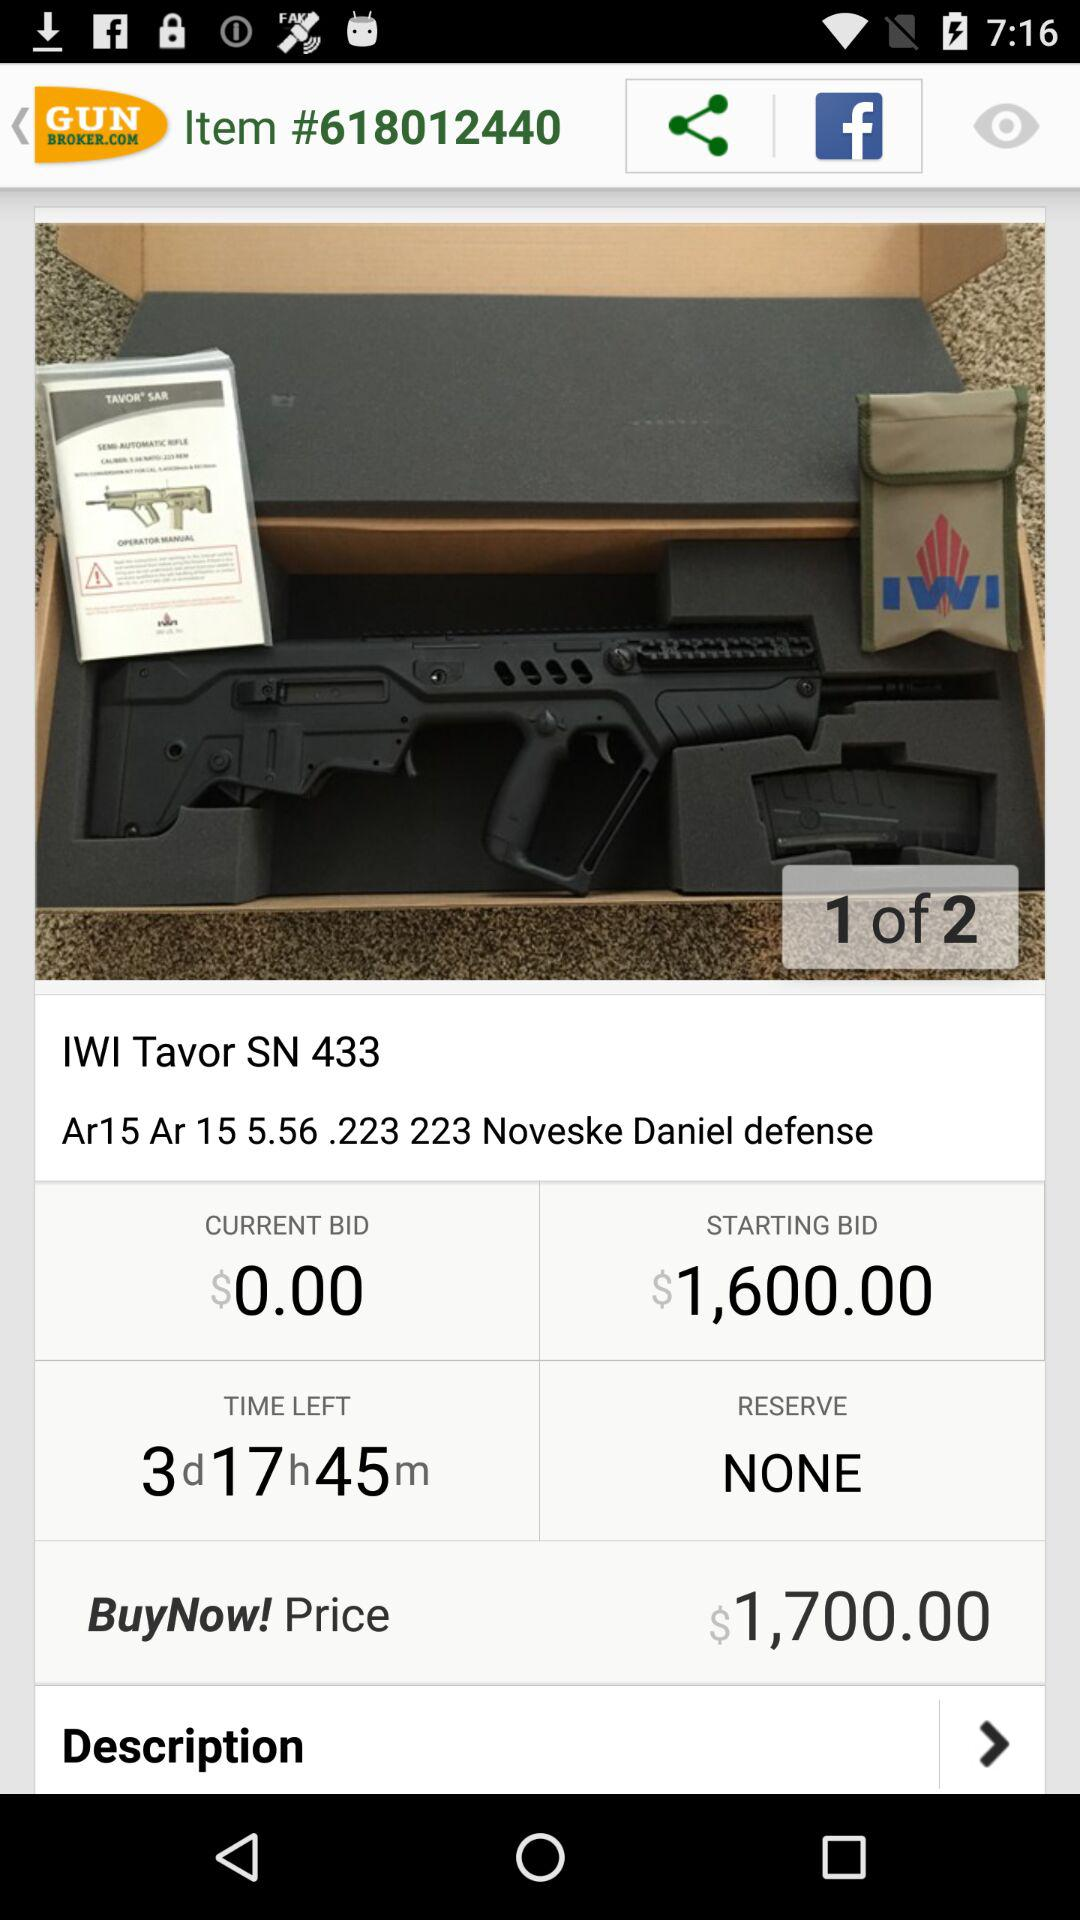What is the current bid? The current bid is $0.00. 